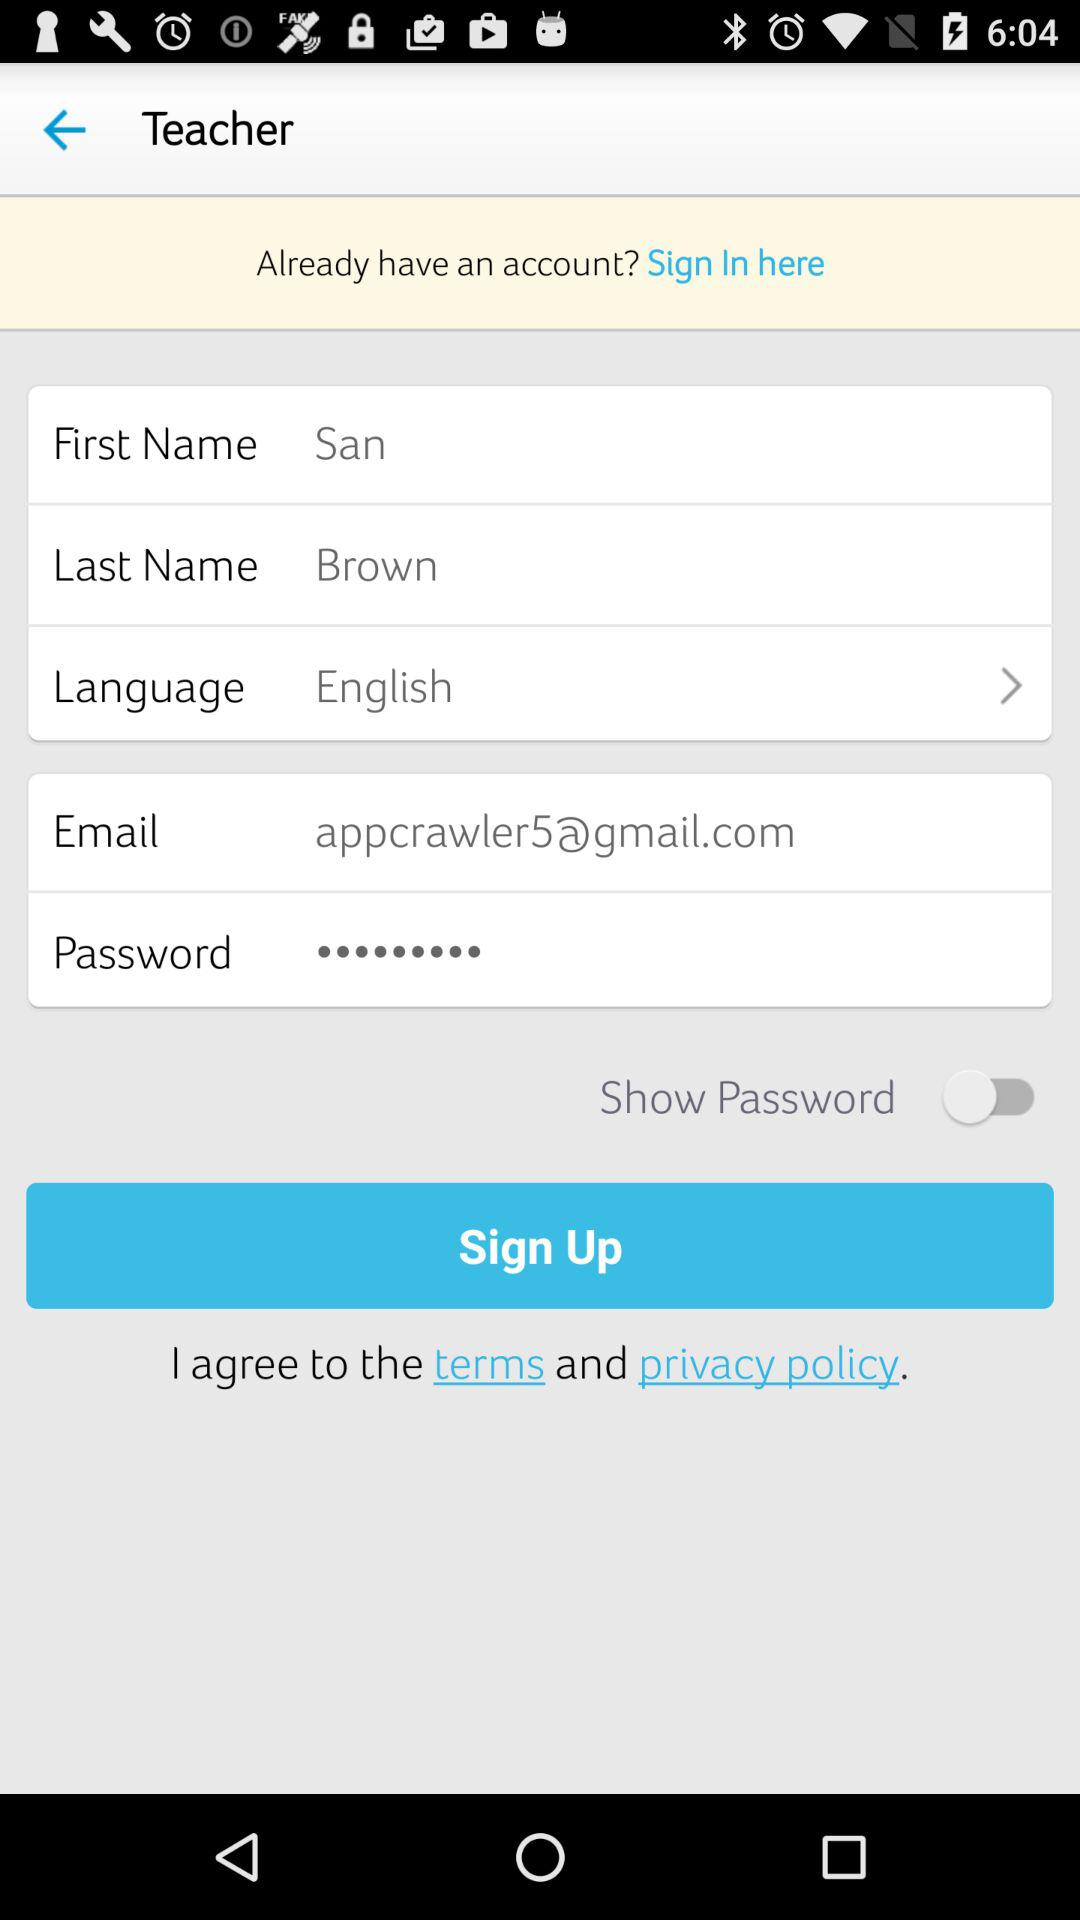What is the email address? The email address is appcrawler5@gmail.com. 